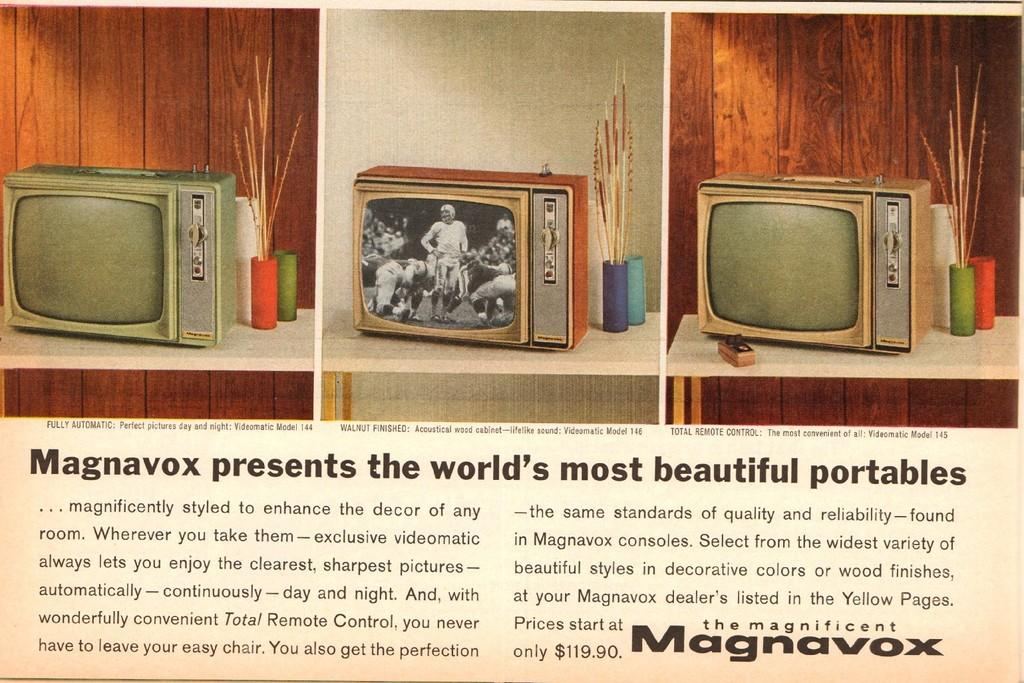<image>
Create a compact narrative representing the image presented. the word Magnavox that is next to some tv's 